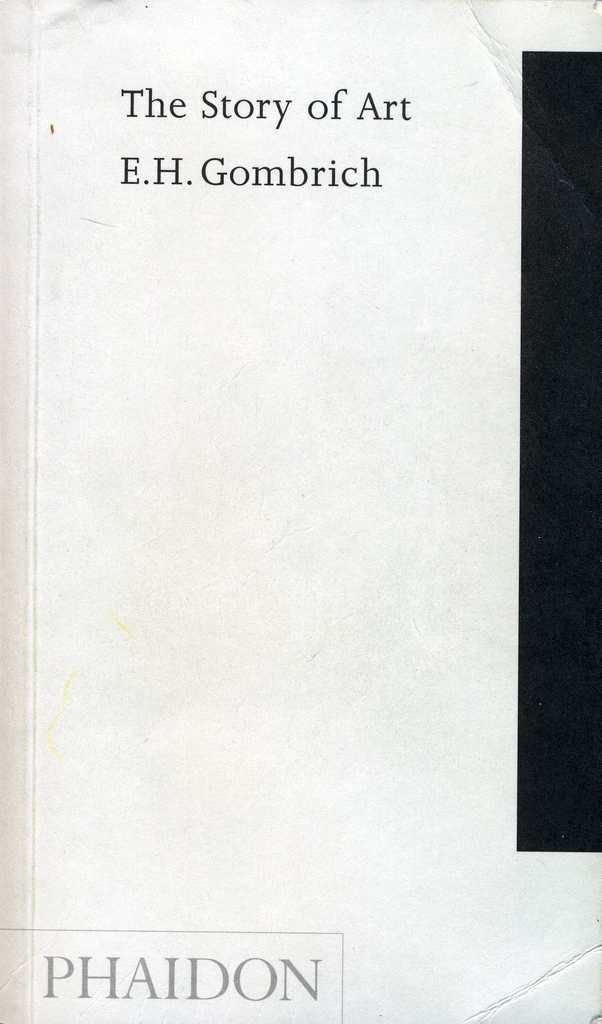<image>
Write a terse but informative summary of the picture. The front cover of a worn book titled, The Story of Art. 